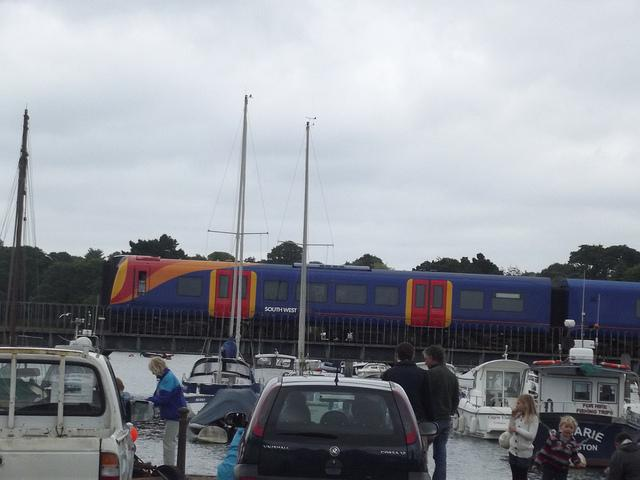Which vehicle holds the most people? train 